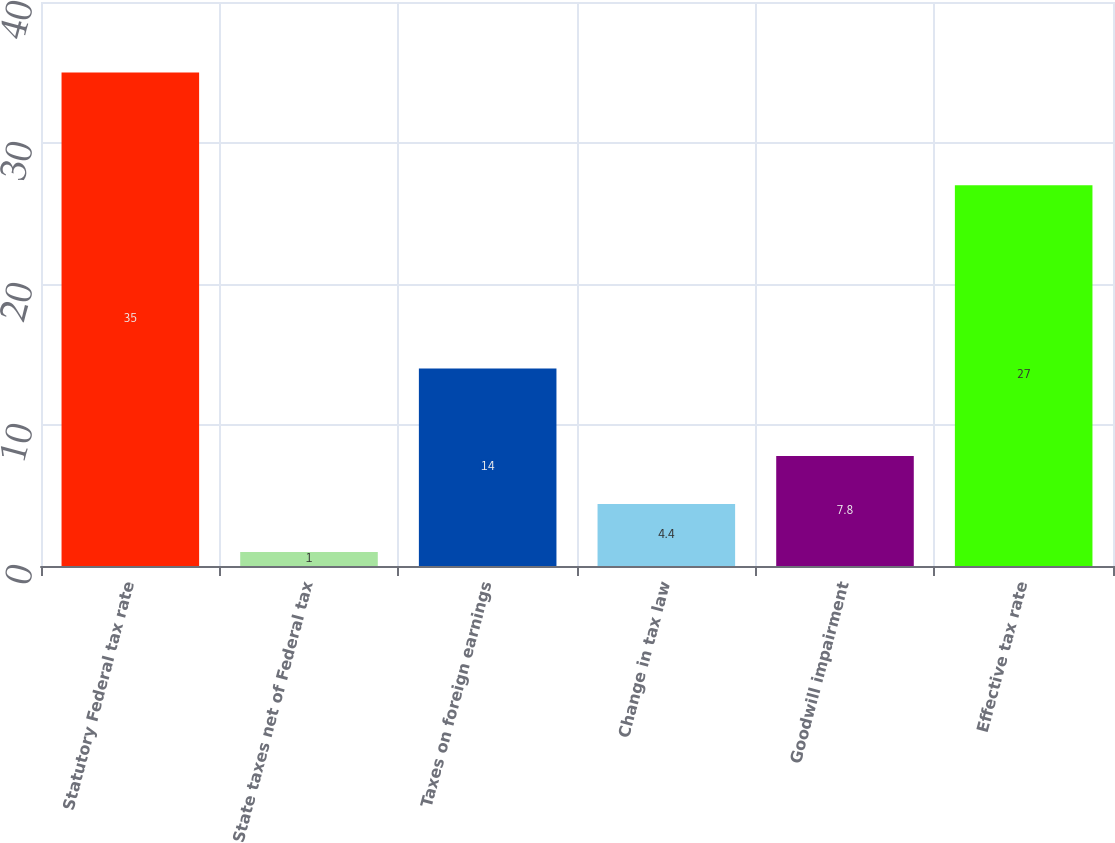<chart> <loc_0><loc_0><loc_500><loc_500><bar_chart><fcel>Statutory Federal tax rate<fcel>State taxes net of Federal tax<fcel>Taxes on foreign earnings<fcel>Change in tax law<fcel>Goodwill impairment<fcel>Effective tax rate<nl><fcel>35<fcel>1<fcel>14<fcel>4.4<fcel>7.8<fcel>27<nl></chart> 